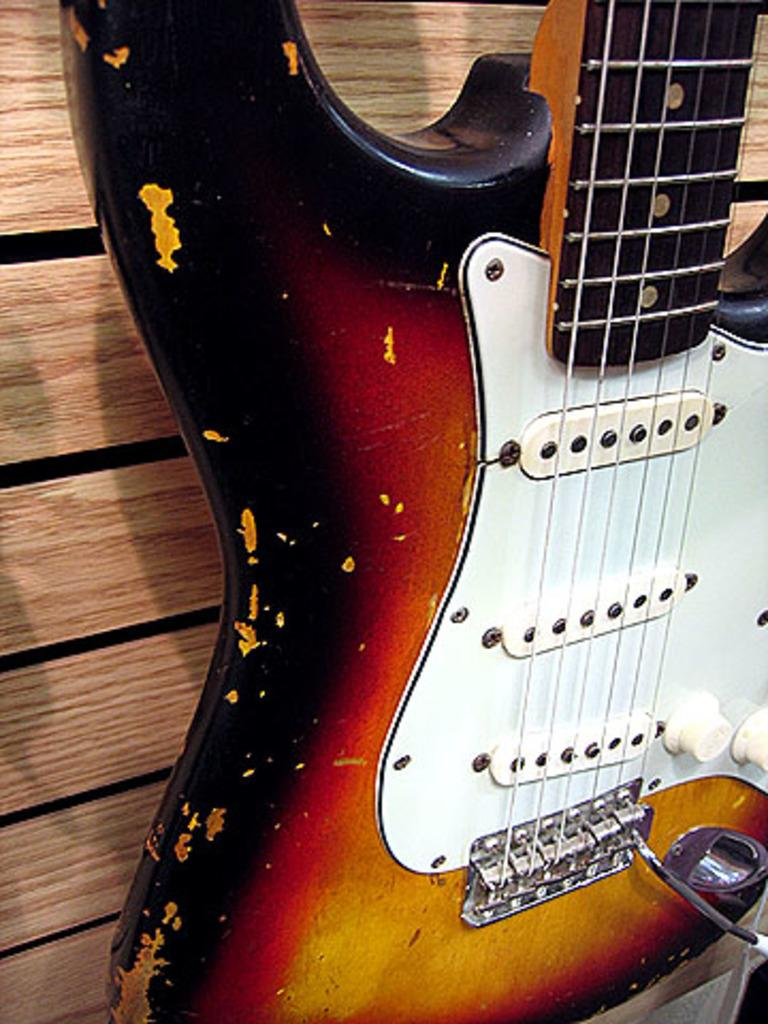What musical instrument is present in the image? There is a guitar in the picture. How many fifths can be seen on the guitar in the image? There is no indication of the number of fifths on the guitar in the image, as the image does not show any specific details about the guitar's structure or tuning. 